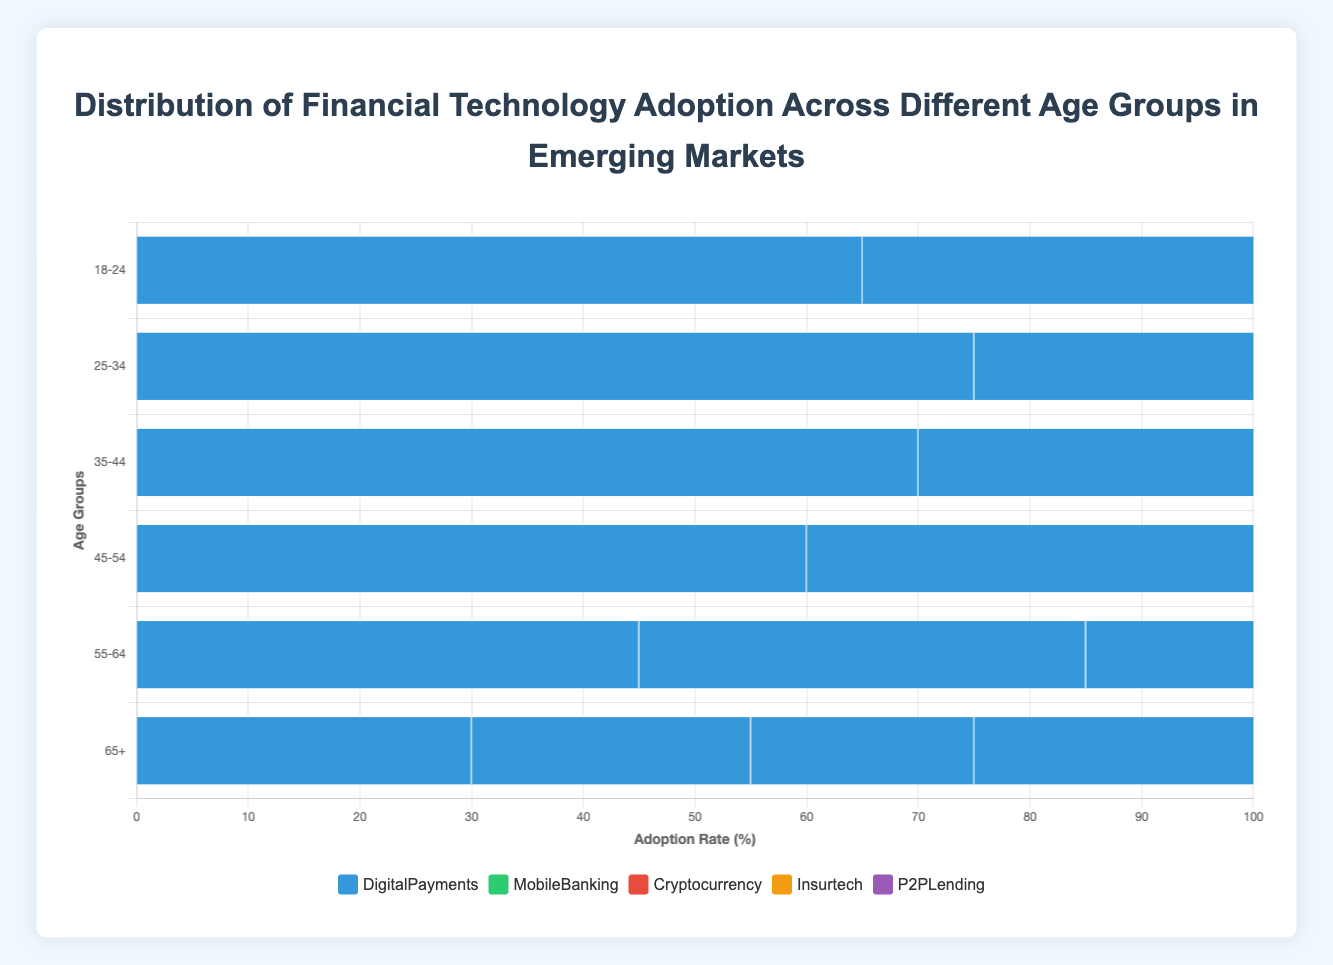What age group has the highest adoption rate for Digital Payments in Indonesia? The chart shows the adoption rates of Digital Payments across different age groups in Indonesia. From the bars, the 25-34 age group has the highest adoption rate at 80%.
Answer: 25-34 Which country shows the lowest adoption rate for Mobile Banking in the 55-64 age group? Comparing the Mobile Banking adoption rates for the 55-64 age group across the countries, Nigeria has the lowest rate at 20%.
Answer: Nigeria How does the Cryptocurrency adoption among the 18-24 age group in Brazil compare to the 18-24 age group in Indonesia? In Brazil, the Cryptocurrency adoption rate for the 18-24 age group is 25%. In Indonesia, it is 35%. Therefore, Indonesia has a higher adoption rate by 10 percentage points.
Answer: Indonesia is higher by 10% What is the combined adoption rate for Insurtech in the 45-54 age group across all countries? Sum the adoption rates of Insurtech for the 45-54 age group across India (20), Brazil (15), Nigeria (10), Indonesia (25), and Mexico (20). The total is 20 + 15 + 10 + 25 + 20 = 90%.
Answer: 90% Is the adoption rate of P2P Lending for the 35-44 age group in Mexico higher than in India? The adoption rate for the 35-44 age group in Mexico is 25%, whereas in India, it is also 25%. Hence, the adoption rates are equal.
Answer: Equal What proportion of the adoption rate for Digital Payments in the 18-24 age group in Nigeria is relative to Indonesia? The adoption rate for Digital Payments in the 18-24 age group in Nigeria is 55%, while in Indonesia it is 70%. The proportion is 55/70, which simplifies to approximately 0.79 or 79%.
Answer: 79% Compare the overall trend of Mobile Banking adoption across the age groups for both India and Mexico. In both India and Mexico, Mobile Banking adoption rates generally decrease with increasing age. The rates start higher in younger age groups and drop significantly in older age groups.
Answer: Both decrease with age Among the countries shown, which has the highest adoption rate for Cryptocurrency in the 45-54 age group? The highest adoption rate for Cryptocurrency in the 45-54 age group is in Indonesia, with 30%, compared to Brazil (20%), India (25%), Nigeria (15%), and Mexico (25%).
Answer: Indonesia What is the average adoption rate of Insurtech for all age groups in India? Sum the adoption rates of Insurtech for all age groups in India (25+35+30+20+10+5 = 125) and divide by the number of age groups (6). The average is 125/6 ≈ 20.83%.
Answer: 20.83% In the 65+ age group, which fintech service has the lowest adoption rate in Brazil? Comparing all services for the 65+ age group in Brazil: Digital Payments (25%), Mobile Banking (15%), Cryptocurrency (5%), Insurtech (3%), and P2P Lending (3%). The lowest adoption rates are Cryptocurrency and Insurtech, both at 3%.
Answer: Insurtech and Cryptocurrency 